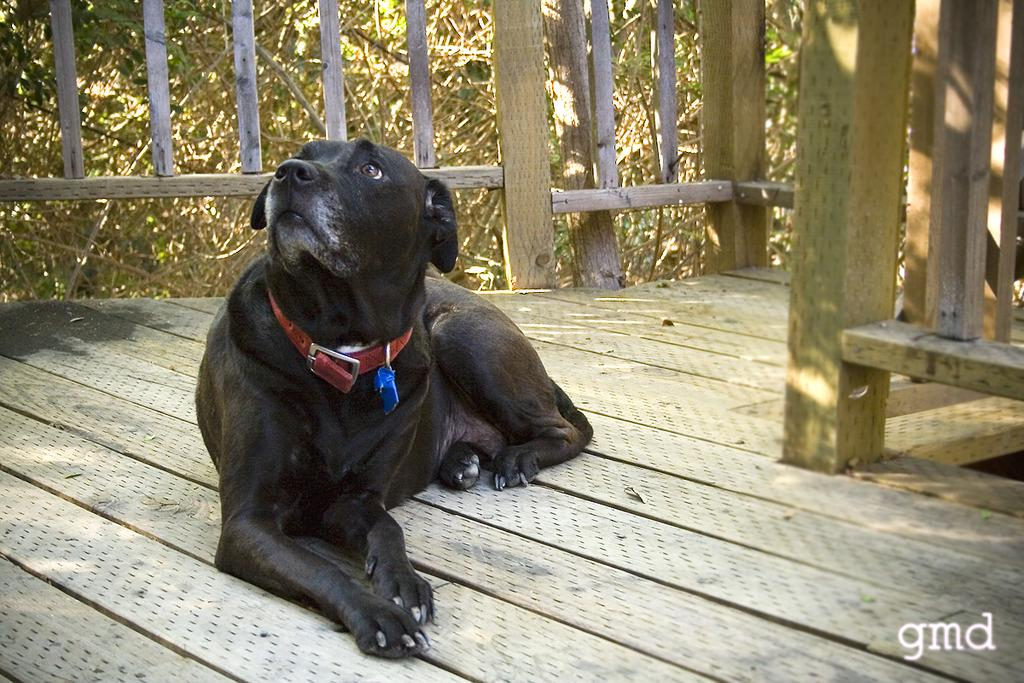What animal is in the center of the image? There is a dog sitting in the center of the image. What can be seen in the background of the image? There is fencing and trees in the background of the image. What is visible at the bottom of the image? The floor is visible at the bottom of the image. What type of toothpaste is the dog using in the image? There is no toothpaste present in the image, and the dog is not using any toothpaste. What time is indicated by the clock in the image? There is no clock present in the image, so it is not possible to determine the time. 